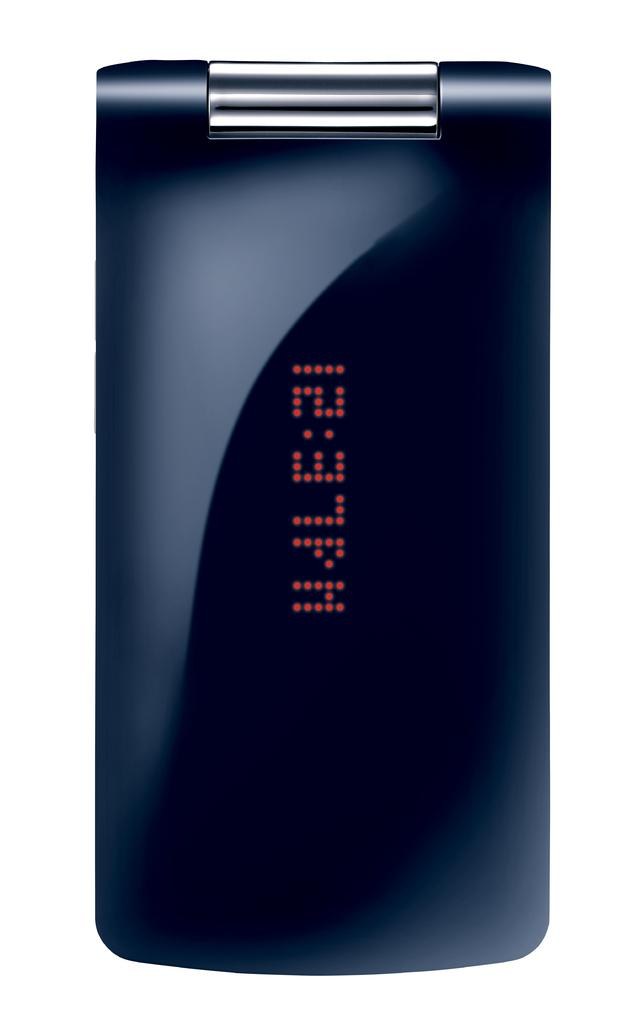What is the main object in the image? There is a black object in the image that resembles a mobile phone. What can be seen on the object? There is text on the object. What color is the background of the image? The background of the image is white. How many points can be seen on the sheet in the image? There is no sheet or points present in the image. 